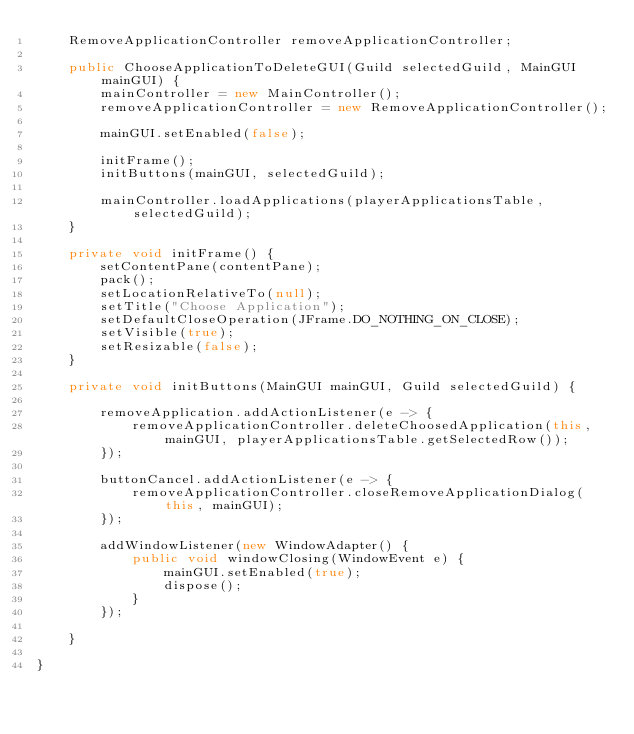<code> <loc_0><loc_0><loc_500><loc_500><_Java_>    RemoveApplicationController removeApplicationController;

    public ChooseApplicationToDeleteGUI(Guild selectedGuild, MainGUI mainGUI) {
        mainController = new MainController();
        removeApplicationController = new RemoveApplicationController();

        mainGUI.setEnabled(false);

        initFrame();
        initButtons(mainGUI, selectedGuild);

        mainController.loadApplications(playerApplicationsTable, selectedGuild);
    }

    private void initFrame() {
        setContentPane(contentPane);
        pack();
        setLocationRelativeTo(null);
        setTitle("Choose Application");
        setDefaultCloseOperation(JFrame.DO_NOTHING_ON_CLOSE);
        setVisible(true);
        setResizable(false);
    }

    private void initButtons(MainGUI mainGUI, Guild selectedGuild) {

        removeApplication.addActionListener(e -> {
            removeApplicationController.deleteChoosedApplication(this, mainGUI, playerApplicationsTable.getSelectedRow());
        });

        buttonCancel.addActionListener(e -> {
            removeApplicationController.closeRemoveApplicationDialog(this, mainGUI);
        });

        addWindowListener(new WindowAdapter() {
            public void windowClosing(WindowEvent e) {
                mainGUI.setEnabled(true);
                dispose();
            }
        });

    }

}
</code> 